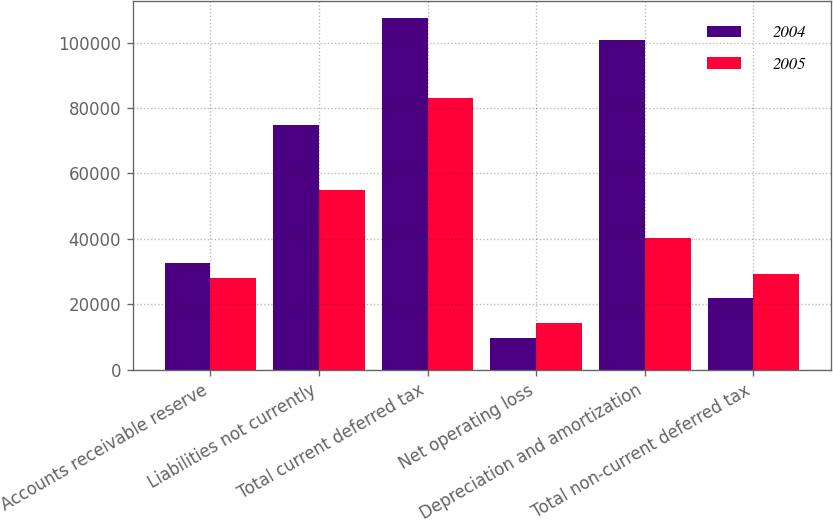Convert chart to OTSL. <chart><loc_0><loc_0><loc_500><loc_500><stacked_bar_chart><ecel><fcel>Accounts receivable reserve<fcel>Liabilities not currently<fcel>Total current deferred tax<fcel>Net operating loss<fcel>Depreciation and amortization<fcel>Total non-current deferred tax<nl><fcel>2004<fcel>32598<fcel>74844<fcel>107442<fcel>9663<fcel>100752<fcel>22018<nl><fcel>2005<fcel>28020<fcel>55010<fcel>83030<fcel>14247<fcel>40407<fcel>29374<nl></chart> 